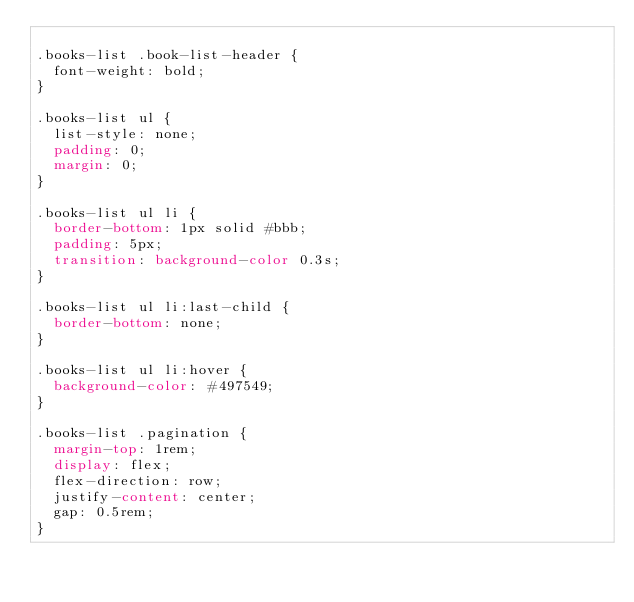<code> <loc_0><loc_0><loc_500><loc_500><_CSS_>
.books-list .book-list-header {
  font-weight: bold;
}

.books-list ul {
  list-style: none;
  padding: 0;
  margin: 0;
}

.books-list ul li {
  border-bottom: 1px solid #bbb;
  padding: 5px;
  transition: background-color 0.3s;
}

.books-list ul li:last-child {
  border-bottom: none;
}

.books-list ul li:hover {
  background-color: #497549;
}

.books-list .pagination {
  margin-top: 1rem;
  display: flex;
  flex-direction: row;
  justify-content: center;
  gap: 0.5rem;
}</code> 